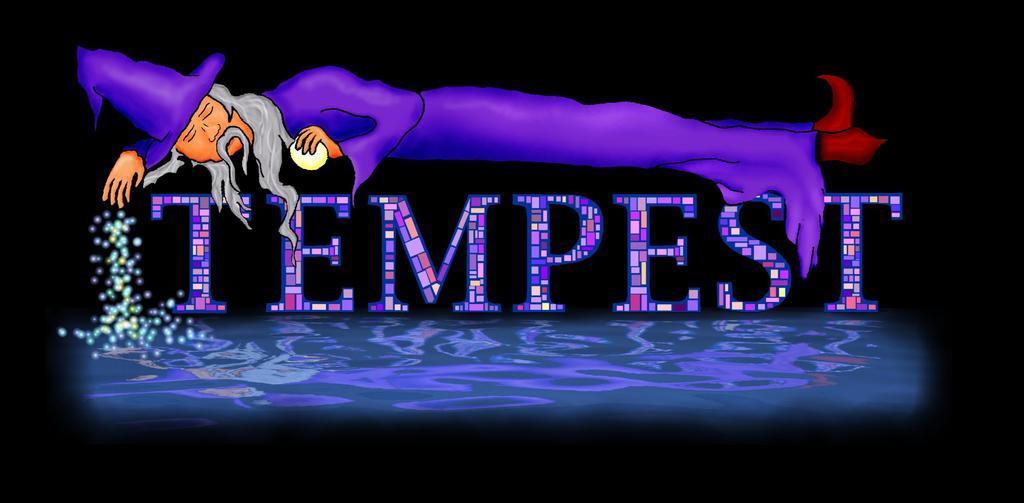How would you summarize this image in a sentence or two? It is an image in which we can see there is some text in the middle. At the bottom there is some water. At the top there is a person who is lying. 